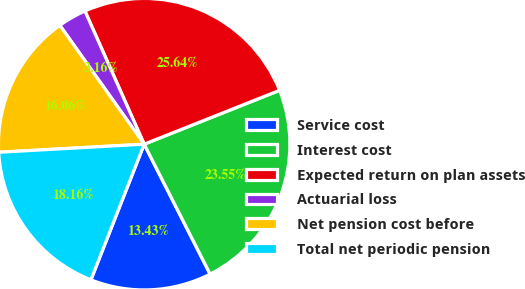<chart> <loc_0><loc_0><loc_500><loc_500><pie_chart><fcel>Service cost<fcel>Interest cost<fcel>Expected return on plan assets<fcel>Actuarial loss<fcel>Net pension cost before<fcel>Total net periodic pension<nl><fcel>13.43%<fcel>23.55%<fcel>25.64%<fcel>3.16%<fcel>16.06%<fcel>18.16%<nl></chart> 